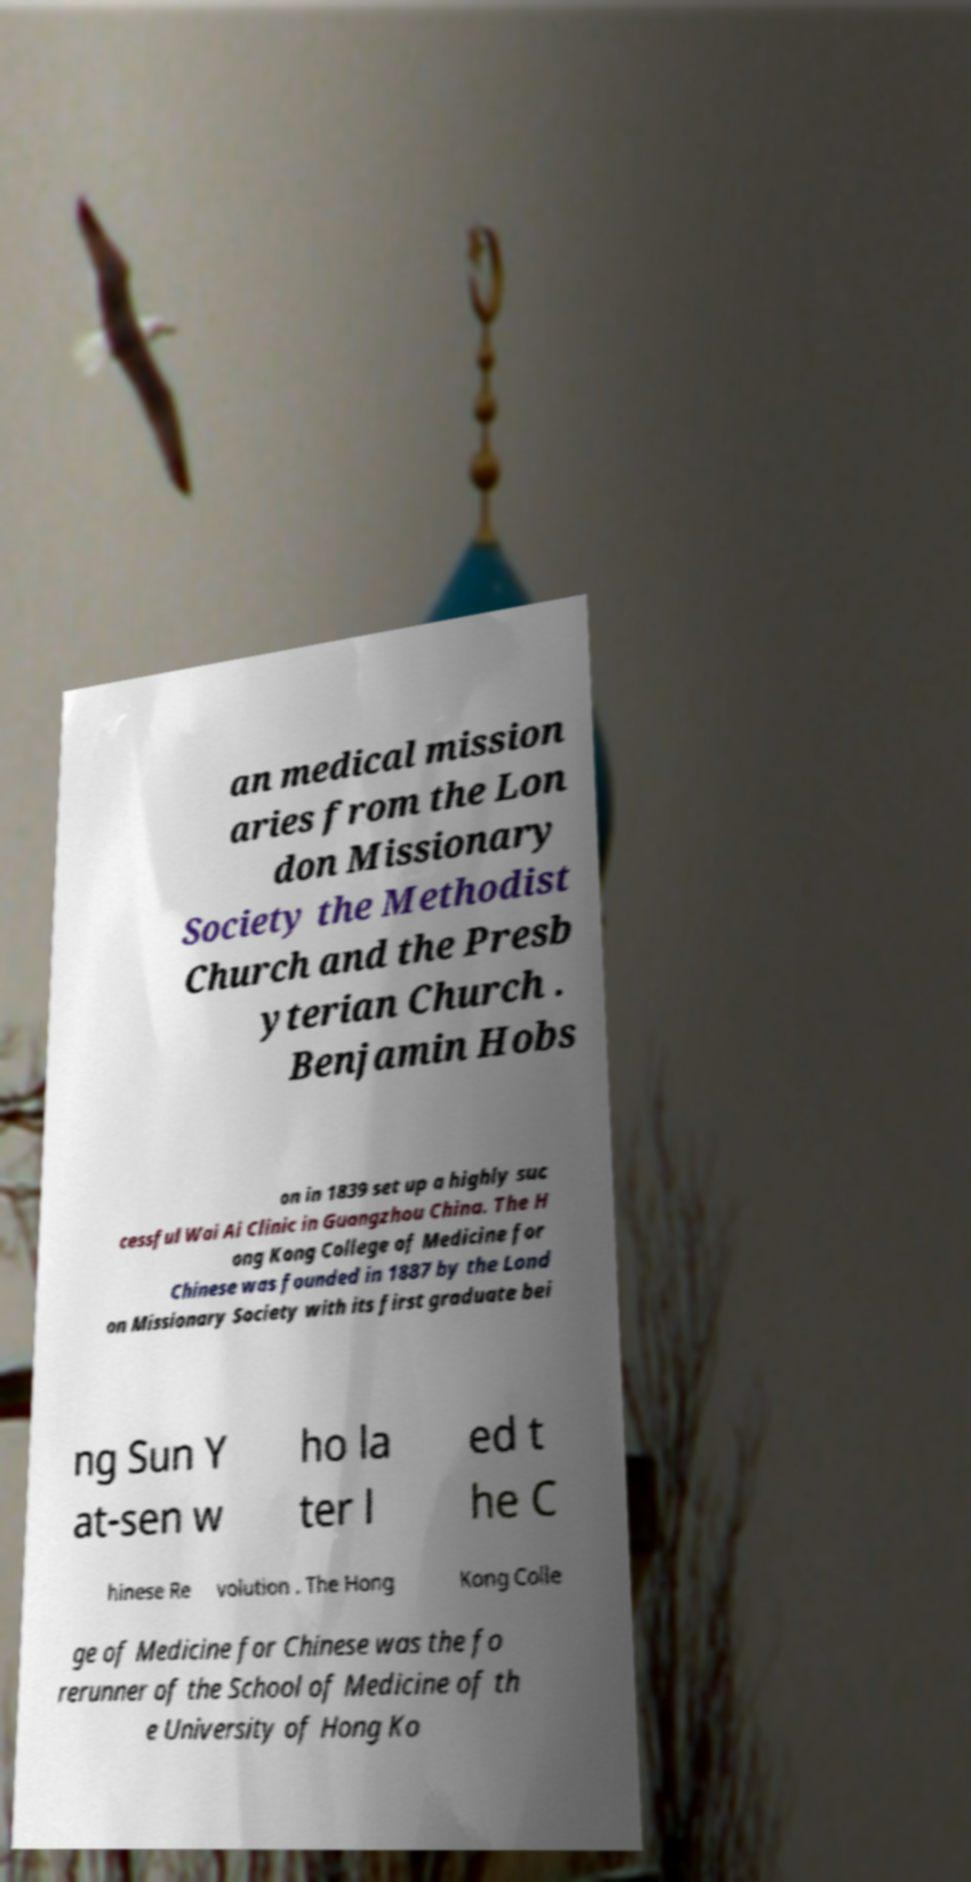Could you extract and type out the text from this image? an medical mission aries from the Lon don Missionary Society the Methodist Church and the Presb yterian Church . Benjamin Hobs on in 1839 set up a highly suc cessful Wai Ai Clinic in Guangzhou China. The H ong Kong College of Medicine for Chinese was founded in 1887 by the Lond on Missionary Society with its first graduate bei ng Sun Y at-sen w ho la ter l ed t he C hinese Re volution . The Hong Kong Colle ge of Medicine for Chinese was the fo rerunner of the School of Medicine of th e University of Hong Ko 